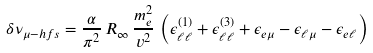Convert formula to latex. <formula><loc_0><loc_0><loc_500><loc_500>\delta \nu _ { \mu - h f s } = \frac { \alpha } { \pi ^ { 2 } } \, R _ { \infty } \, \frac { m _ { e } ^ { 2 } } { v ^ { 2 } } \, \left ( \epsilon _ { \ell \ell } ^ { ( 1 ) } + \epsilon _ { \ell \ell } ^ { ( 3 ) } + \epsilon _ { e \mu } - \epsilon _ { \ell \mu } - \epsilon _ { e \ell } \right )</formula> 